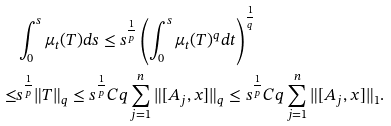<formula> <loc_0><loc_0><loc_500><loc_500>& \int _ { 0 } ^ { s } \mu _ { t } ( T ) d s \leq s ^ { \frac { 1 } { p } } \left ( \int _ { 0 } ^ { s } \mu _ { t } ( T ) ^ { q } d t \right ) ^ { \frac { 1 } { q } } \\ \leq & s ^ { \frac { 1 } { p } } \| T \| _ { q } \leq s ^ { \frac { 1 } { p } } C q \sum _ { j = 1 } ^ { n } \| [ A _ { j } , x ] \| _ { q } \leq s ^ { \frac { 1 } { p } } C q \sum _ { j = 1 } ^ { n } \| [ A _ { j } , x ] \| _ { 1 } .</formula> 